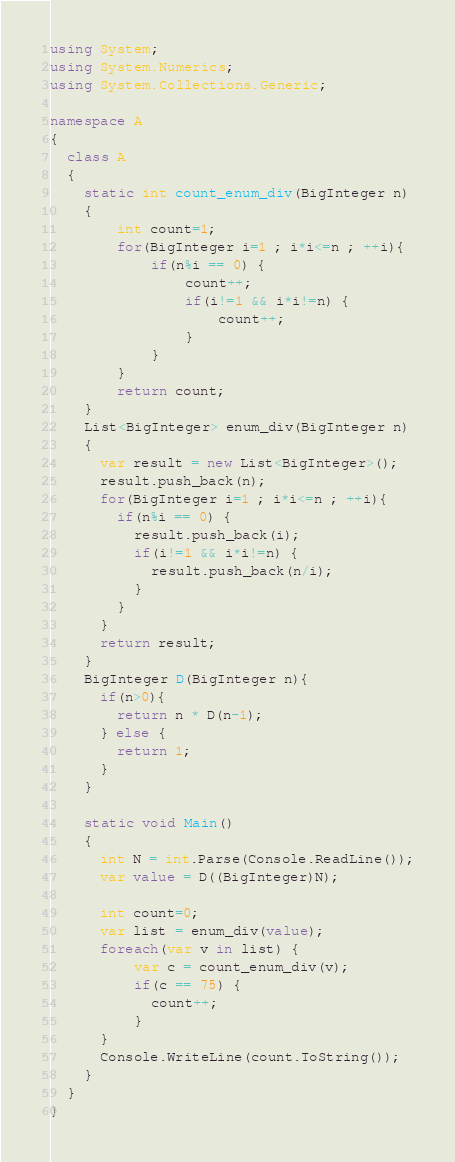Convert code to text. <code><loc_0><loc_0><loc_500><loc_500><_C#_>using System;
using System.Numerics;
using System.Collections.Generic;

namespace A
{
  class A 
  {
    static int count_enum_div(BigInteger n)
    {
    	int count=1;
    	for(BigInteger i=1 ; i*i<=n ; ++i){
    		if(n%i == 0) {
                count++;
    			if(i!=1 && i*i!=n) {
                    count++;
    			}
    		}
    	}
    	return count;
    }
    List<BigInteger> enum_div(BigInteger n)
    {
      var result = new List<BigInteger>();
      result.push_back(n);
      for(BigInteger i=1 ; i*i<=n ; ++i){
        if(n%i == 0) {
          result.push_back(i);
          if(i!=1 && i*i!=n) {
            result.push_back(n/i);
          }
        }
      }
      return result;
    }
    BigInteger D(BigInteger n){
      if(n>0){
        return n * D(n-1);
      } else {
        return 1;
      }
    }
    
    static void Main() 
    {
      int N = int.Parse(Console.ReadLine());
      var value = D((BigInteger)N);
      
      int count=0;
      var list = enum_div(value);
      foreach(var v in list) {
          var c = count_enum_div(v);
          if(c == 75) {
            count++;
          }
      }
      Console.WriteLine(count.ToString());
    }
  }
}</code> 